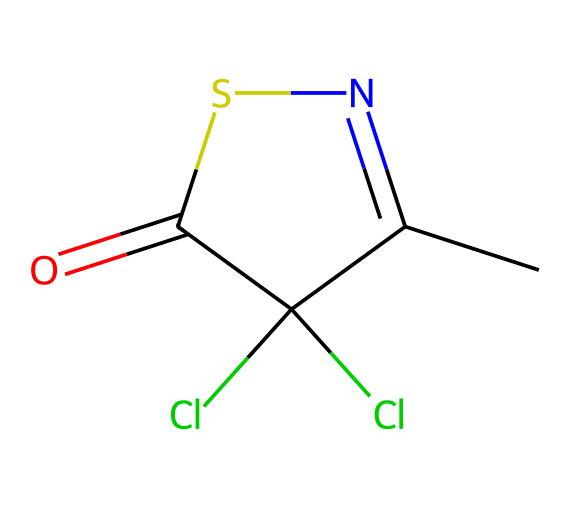How many chlorine atoms are present in methylchloroisothiazolinone? By examining the SMILES representation, "CC1=NSC(=O)C1(Cl)Cl", we can identify two instances of "Cl", indicating the presence of two chlorine atoms attached to the structure.
Answer: 2 What is the main functional group in this compound? Looking at the structural formula derived from the SMILES, the presence of "C(=O)" indicates a carbonyl group, and the "S" indicates a thiazole-related structure, confirming that the thiazolinone structure is the main functional group.
Answer: thiazolinone How many rings does methylchloroisothiazolinone have? The 'C1' in the SMILES denotes that there is at least one cyclic structure, and by examining the connections, we conclude that there is one ring in the structure.
Answer: 1 What type of chemical is methylchloroisothiazolinone primarily classified as? This compound contains preservatives noted for their ability to prevent microbial growth, which classifies it specifically within the category of preservatives.
Answer: preservative Does methylchloroisothiazolinone contain nitrogen? The presence of the letter "N" in the SMILES indicates that there is a nitrogen atom in the structure, confirming this compound contains nitrogen.
Answer: yes 